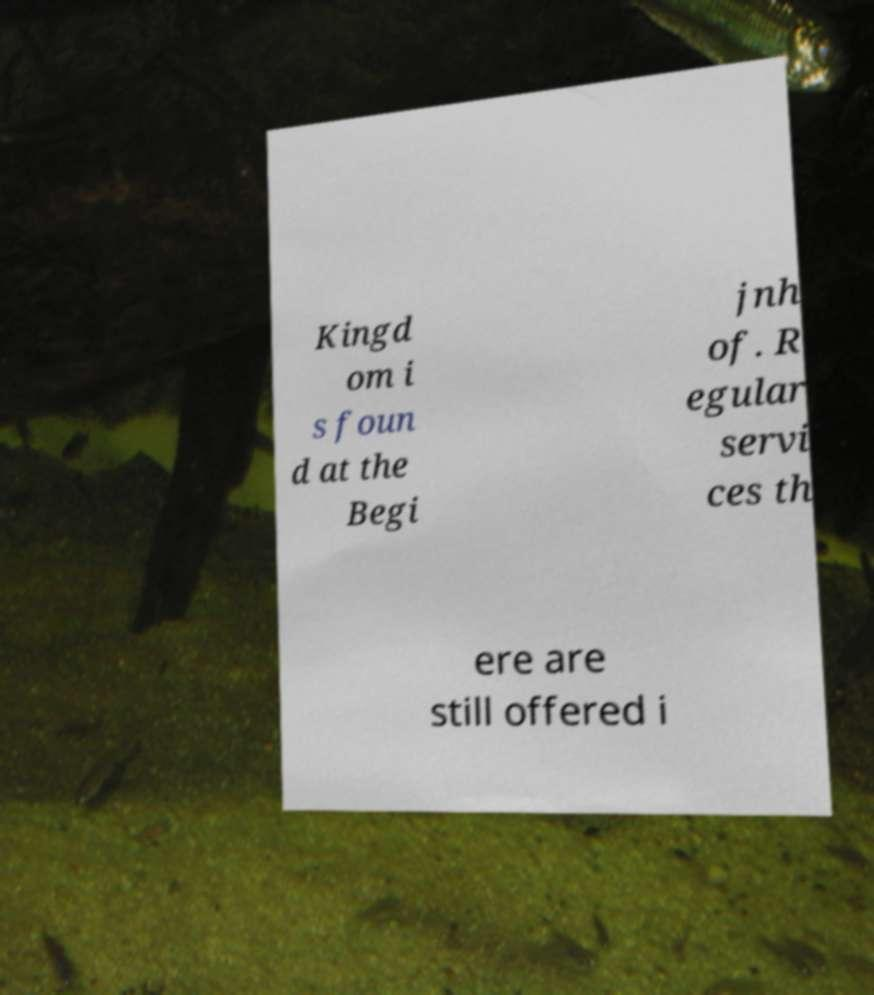Can you accurately transcribe the text from the provided image for me? Kingd om i s foun d at the Begi jnh of. R egular servi ces th ere are still offered i 